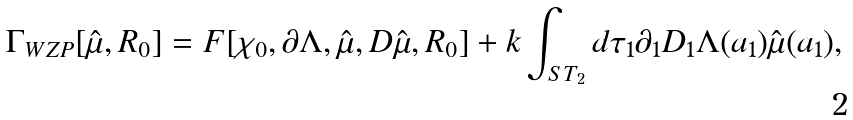Convert formula to latex. <formula><loc_0><loc_0><loc_500><loc_500>\Gamma _ { W Z P } [ { \hat { \mu } } , R _ { 0 } ] = F [ \chi _ { 0 } , \partial \Lambda , { \hat { \mu } } , D { \hat { \mu } } , R _ { 0 } ] + k \int _ { S T _ { 2 } } d \tau _ { 1 } \partial _ { 1 } D _ { 1 } \Lambda ( a _ { 1 } ) { \hat { \mu } } ( a _ { 1 } ) ,</formula> 